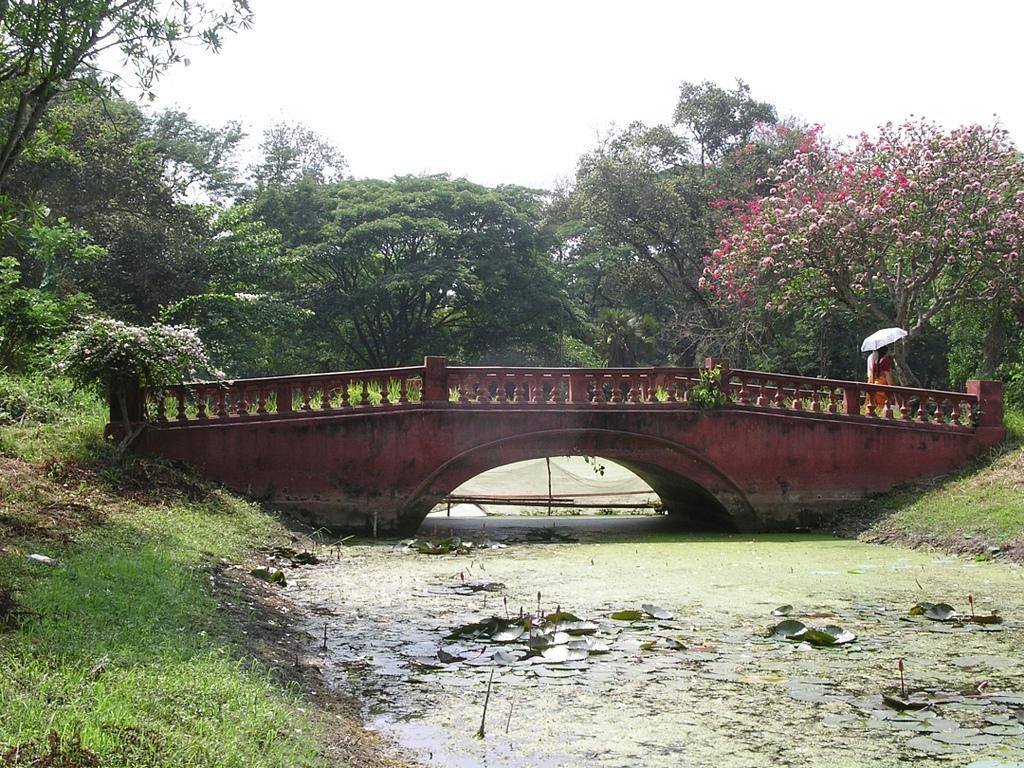In one or two sentences, can you explain what this image depicts? In this image we can see two persons walking on the bridge, they are holding an umbrella, there are plants, trees, flowers, grass, also we can see the lake and the sky. 